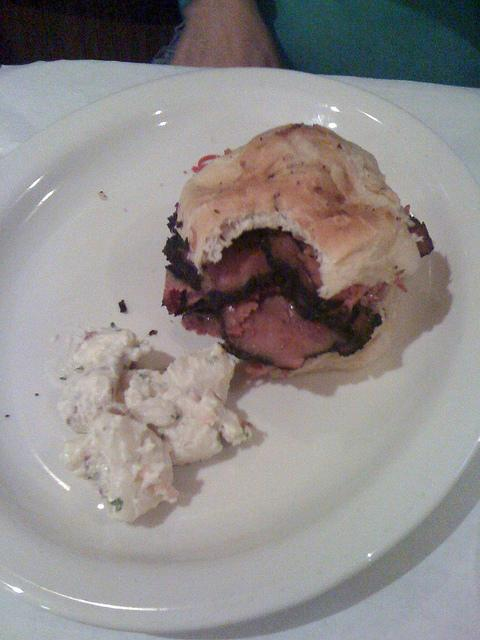What is the side dish? potato salad 